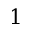<formula> <loc_0><loc_0><loc_500><loc_500>1</formula> 